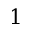<formula> <loc_0><loc_0><loc_500><loc_500>1</formula> 